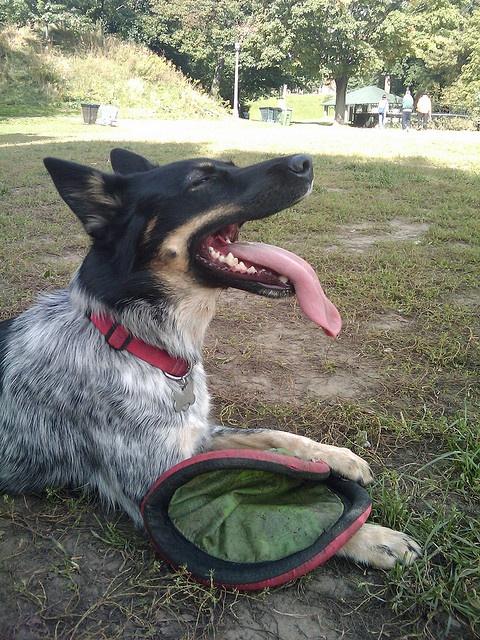Describe the objects in this image and their specific colors. I can see dog in khaki, black, gray, darkgray, and lightgray tones, people in khaki, white, darkgray, gray, and brown tones, people in khaki, white, darkgray, gray, and lightblue tones, and people in khaki, white, darkgray, and gray tones in this image. 